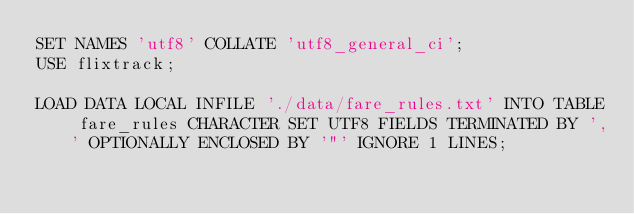<code> <loc_0><loc_0><loc_500><loc_500><_SQL_>SET NAMES 'utf8' COLLATE 'utf8_general_ci';
USE flixtrack;

LOAD DATA LOCAL INFILE './data/fare_rules.txt' INTO TABLE fare_rules CHARACTER SET UTF8 FIELDS TERMINATED BY ',' OPTIONALLY ENCLOSED BY '"' IGNORE 1 LINES;
</code> 